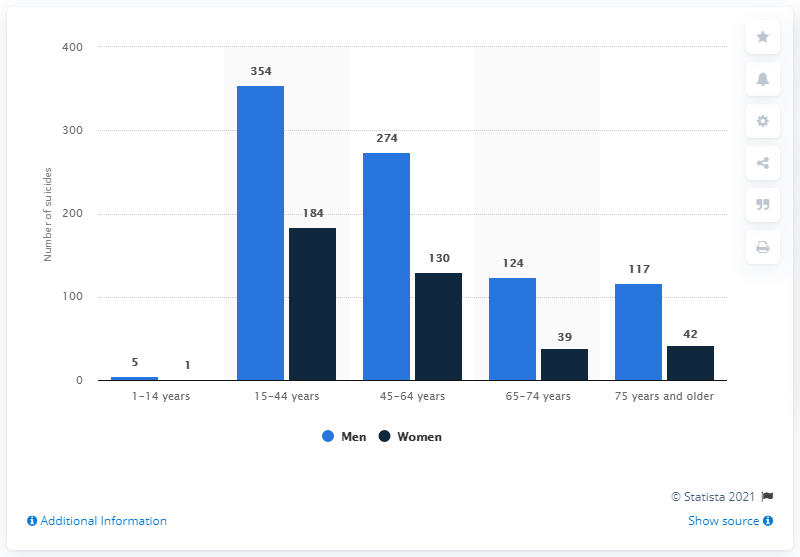Give some essential details in this illustration. The difference between the highest number of suicides by men and the minimum number of suicides by women over the years is 353. In 2019, there were 354 suicides committed among men aged 14 to 44 in Sweden. The age group that recorded the highest number of suicides by men over the years is 15-44 years. 